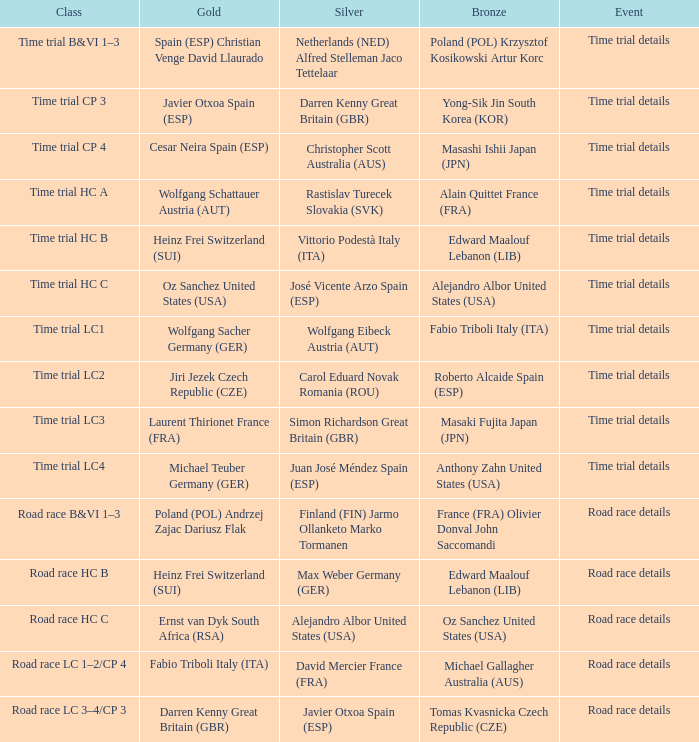What is the event when the class is time trial hc a? Time trial details. 